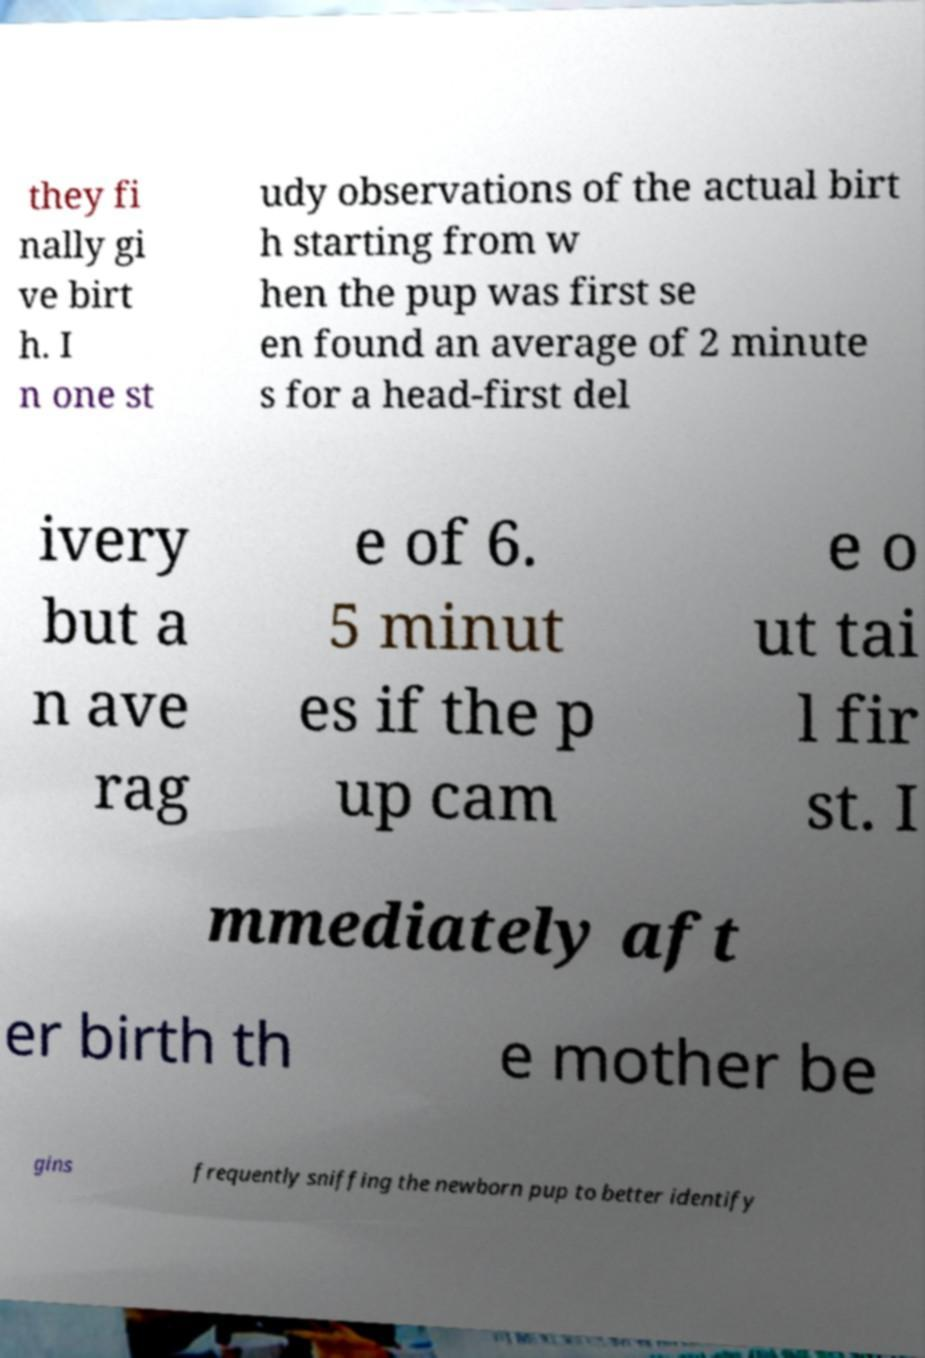There's text embedded in this image that I need extracted. Can you transcribe it verbatim? they fi nally gi ve birt h. I n one st udy observations of the actual birt h starting from w hen the pup was first se en found an average of 2 minute s for a head-first del ivery but a n ave rag e of 6. 5 minut es if the p up cam e o ut tai l fir st. I mmediately aft er birth th e mother be gins frequently sniffing the newborn pup to better identify 